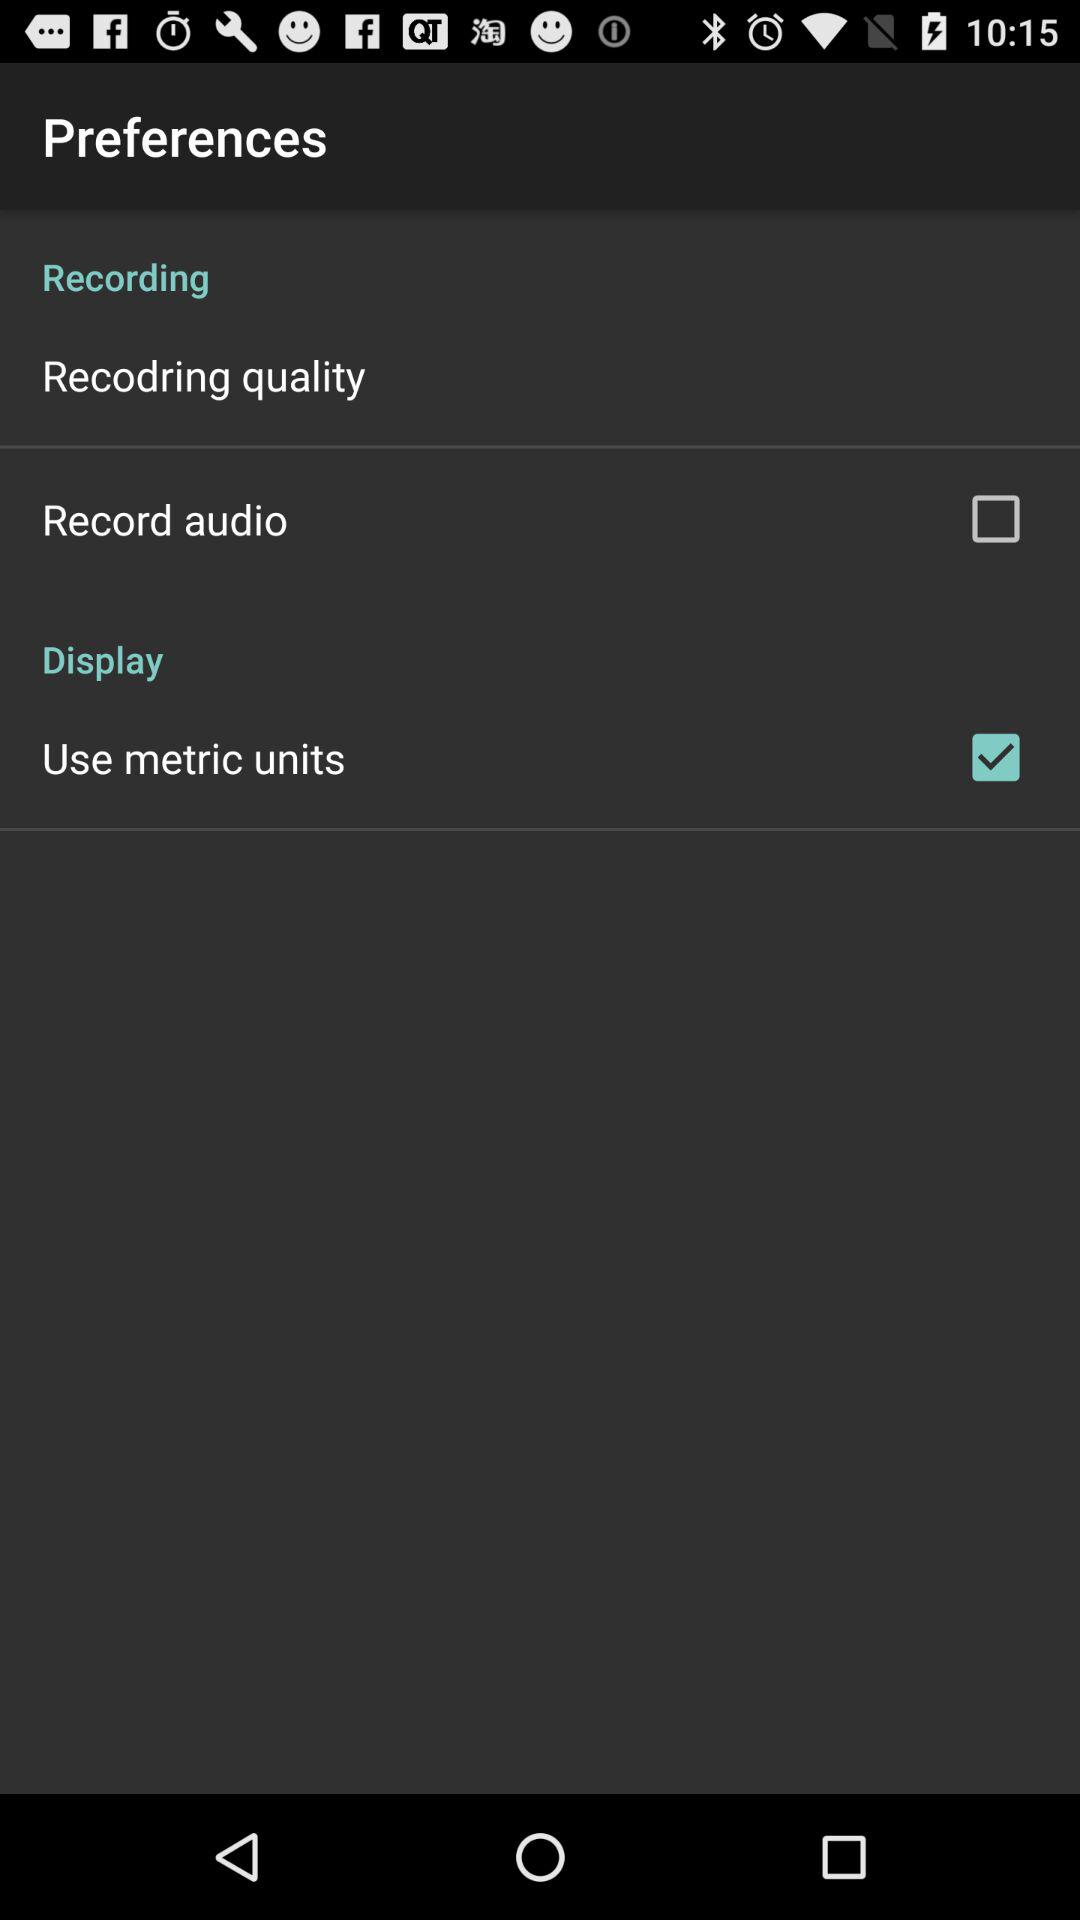Which preferences are marked as checked? The preference that is marked as checked is "Use metric units". 